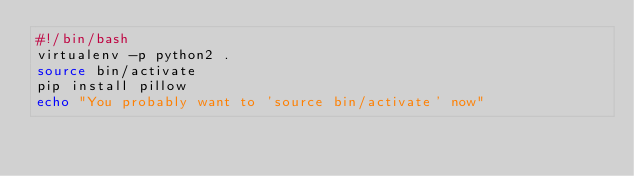<code> <loc_0><loc_0><loc_500><loc_500><_Bash_>#!/bin/bash
virtualenv -p python2 .
source bin/activate
pip install pillow
echo "You probably want to 'source bin/activate' now"
</code> 